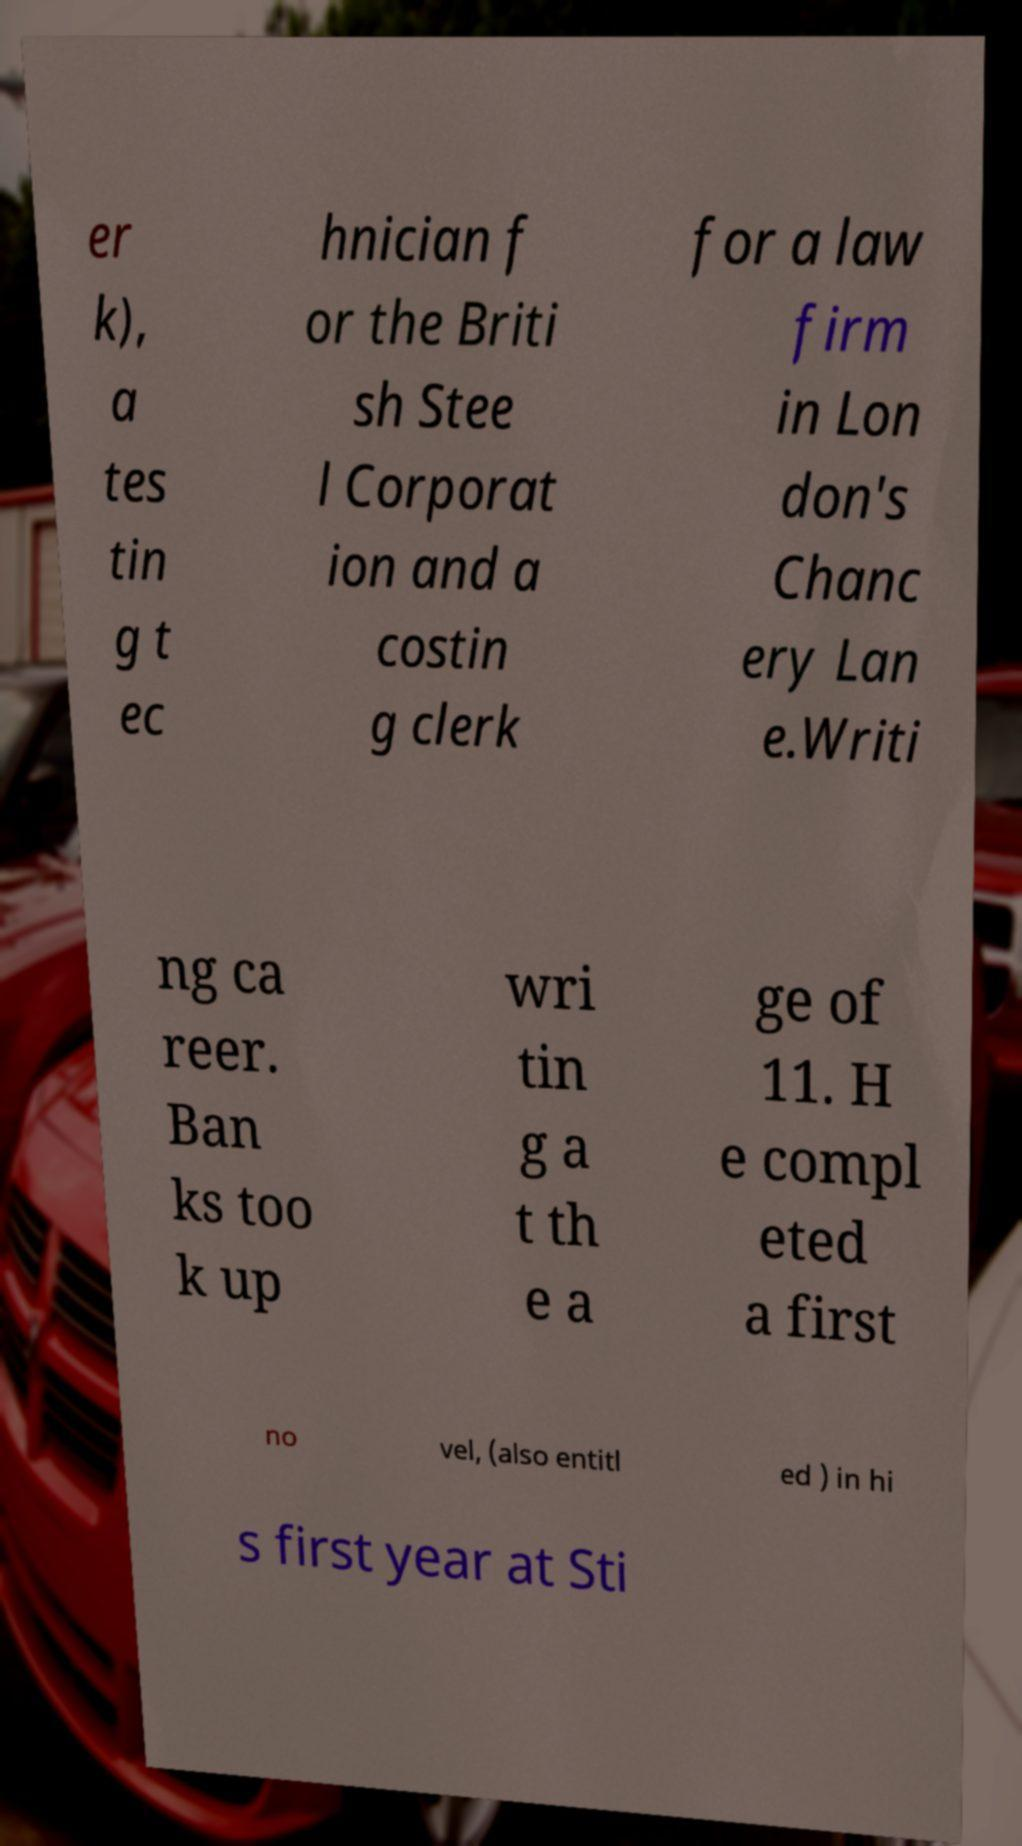Please read and relay the text visible in this image. What does it say? er k), a tes tin g t ec hnician f or the Briti sh Stee l Corporat ion and a costin g clerk for a law firm in Lon don's Chanc ery Lan e.Writi ng ca reer. Ban ks too k up wri tin g a t th e a ge of 11. H e compl eted a first no vel, (also entitl ed ) in hi s first year at Sti 